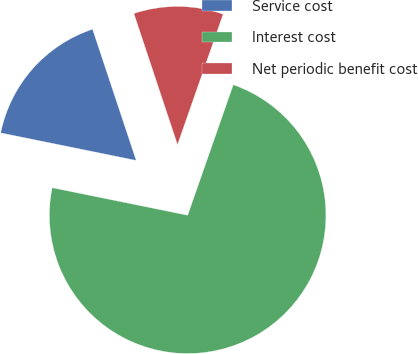Convert chart to OTSL. <chart><loc_0><loc_0><loc_500><loc_500><pie_chart><fcel>Service cost<fcel>Interest cost<fcel>Net periodic benefit cost<nl><fcel>16.7%<fcel>72.84%<fcel>10.46%<nl></chart> 